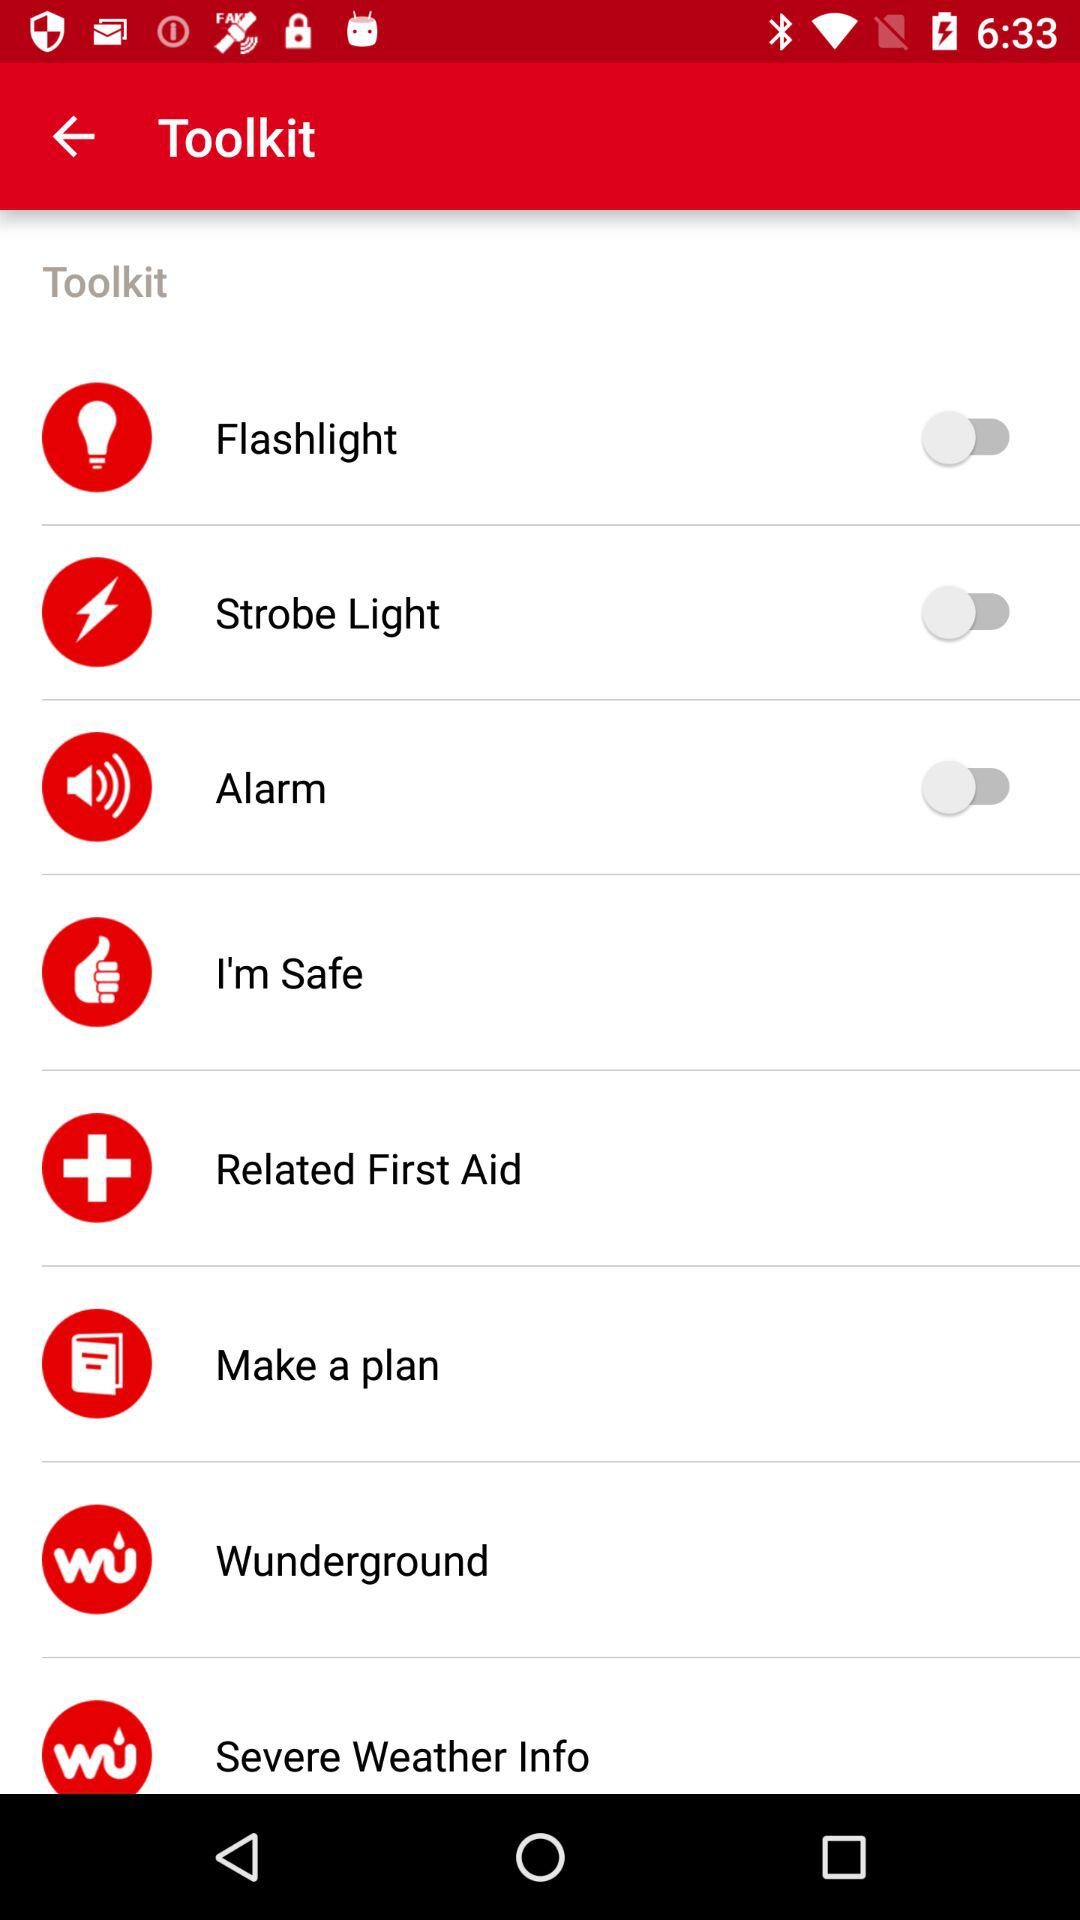What is the status of "Alarm"? The status of "Alarm" is "off". 